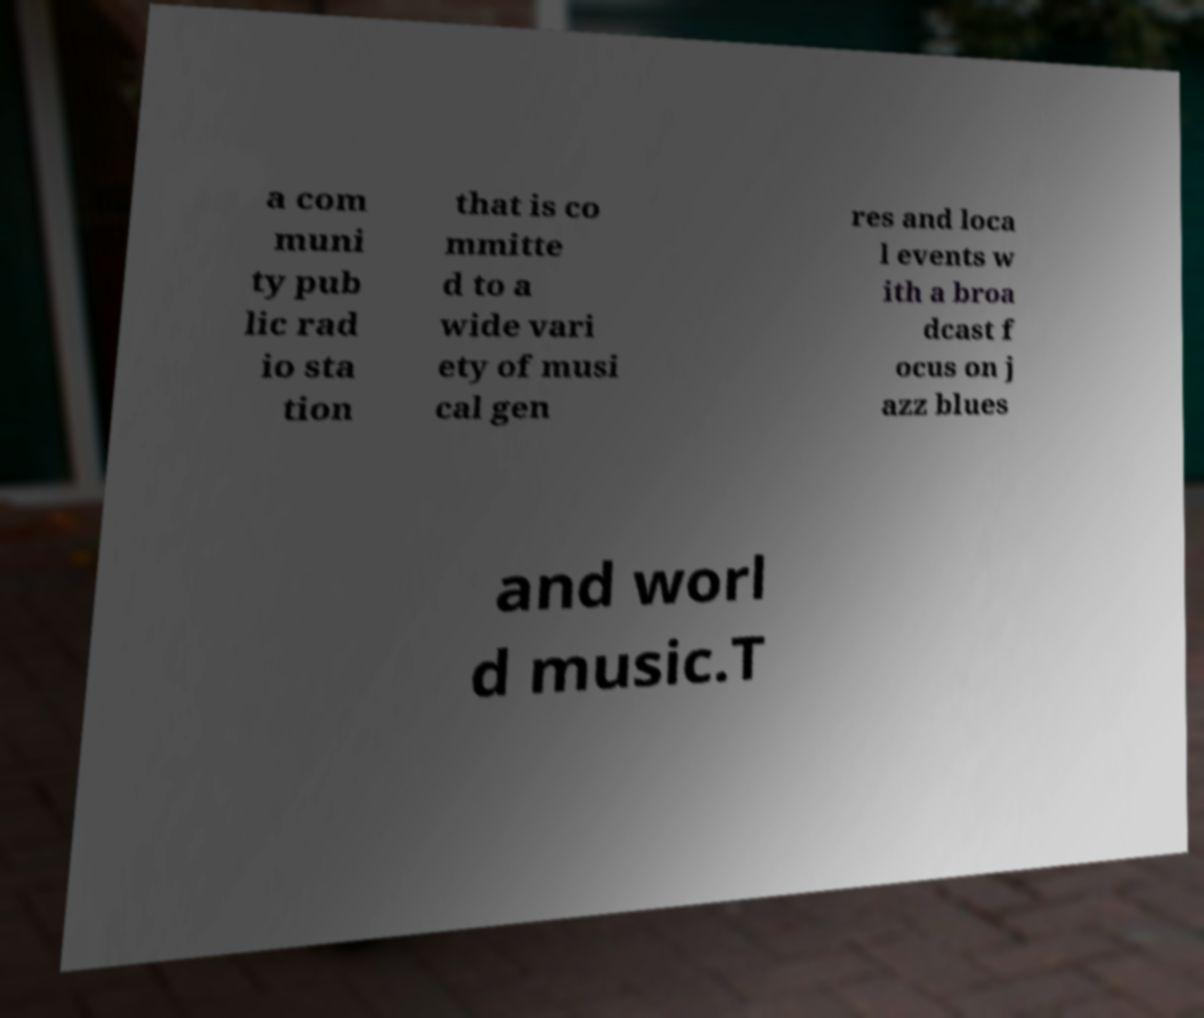Could you extract and type out the text from this image? a com muni ty pub lic rad io sta tion that is co mmitte d to a wide vari ety of musi cal gen res and loca l events w ith a broa dcast f ocus on j azz blues and worl d music.T 